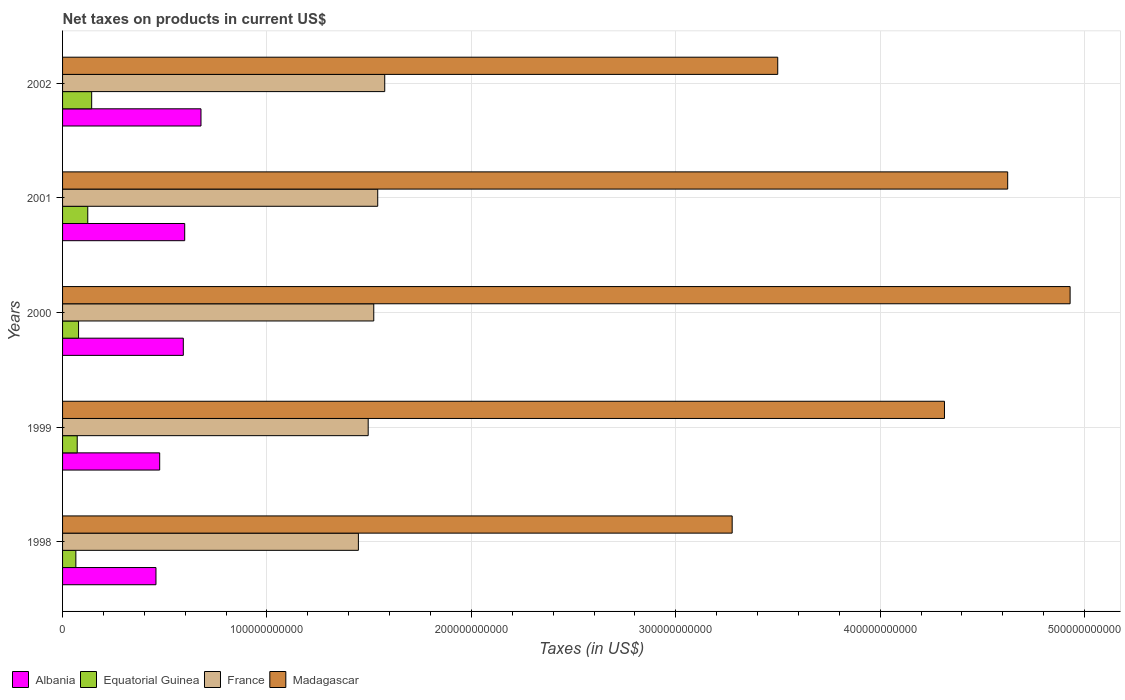How many different coloured bars are there?
Make the answer very short. 4. How many groups of bars are there?
Provide a succinct answer. 5. Are the number of bars per tick equal to the number of legend labels?
Provide a short and direct response. Yes. How many bars are there on the 5th tick from the top?
Your answer should be compact. 4. How many bars are there on the 3rd tick from the bottom?
Make the answer very short. 4. What is the net taxes on products in Madagascar in 2001?
Ensure brevity in your answer.  4.62e+11. Across all years, what is the maximum net taxes on products in Madagascar?
Offer a terse response. 4.93e+11. Across all years, what is the minimum net taxes on products in Equatorial Guinea?
Your response must be concise. 6.50e+09. In which year was the net taxes on products in Equatorial Guinea maximum?
Give a very brief answer. 2002. What is the total net taxes on products in Albania in the graph?
Offer a very short reply. 2.80e+11. What is the difference between the net taxes on products in Equatorial Guinea in 2000 and that in 2002?
Provide a succinct answer. -6.41e+09. What is the difference between the net taxes on products in Albania in 2001 and the net taxes on products in Madagascar in 2002?
Offer a very short reply. -2.90e+11. What is the average net taxes on products in France per year?
Keep it short and to the point. 1.52e+11. In the year 2002, what is the difference between the net taxes on products in France and net taxes on products in Albania?
Offer a very short reply. 8.99e+1. In how many years, is the net taxes on products in Albania greater than 80000000000 US$?
Give a very brief answer. 0. What is the ratio of the net taxes on products in Madagascar in 1998 to that in 2000?
Offer a terse response. 0.66. Is the net taxes on products in Equatorial Guinea in 1998 less than that in 2001?
Provide a succinct answer. Yes. What is the difference between the highest and the second highest net taxes on products in France?
Your response must be concise. 3.43e+09. What is the difference between the highest and the lowest net taxes on products in Equatorial Guinea?
Your answer should be compact. 7.74e+09. What does the 1st bar from the top in 2001 represents?
Your response must be concise. Madagascar. What does the 2nd bar from the bottom in 2002 represents?
Your response must be concise. Equatorial Guinea. How many bars are there?
Ensure brevity in your answer.  20. Are all the bars in the graph horizontal?
Ensure brevity in your answer.  Yes. How many years are there in the graph?
Provide a succinct answer. 5. What is the difference between two consecutive major ticks on the X-axis?
Offer a very short reply. 1.00e+11. Are the values on the major ticks of X-axis written in scientific E-notation?
Ensure brevity in your answer.  No. Where does the legend appear in the graph?
Make the answer very short. Bottom left. How are the legend labels stacked?
Your response must be concise. Horizontal. What is the title of the graph?
Offer a terse response. Net taxes on products in current US$. What is the label or title of the X-axis?
Make the answer very short. Taxes (in US$). What is the Taxes (in US$) in Albania in 1998?
Keep it short and to the point. 4.57e+1. What is the Taxes (in US$) of Equatorial Guinea in 1998?
Your answer should be compact. 6.50e+09. What is the Taxes (in US$) of France in 1998?
Keep it short and to the point. 1.45e+11. What is the Taxes (in US$) of Madagascar in 1998?
Your response must be concise. 3.28e+11. What is the Taxes (in US$) in Albania in 1999?
Keep it short and to the point. 4.75e+1. What is the Taxes (in US$) in Equatorial Guinea in 1999?
Ensure brevity in your answer.  7.16e+09. What is the Taxes (in US$) in France in 1999?
Give a very brief answer. 1.50e+11. What is the Taxes (in US$) of Madagascar in 1999?
Offer a terse response. 4.31e+11. What is the Taxes (in US$) in Albania in 2000?
Your answer should be very brief. 5.91e+1. What is the Taxes (in US$) of Equatorial Guinea in 2000?
Keep it short and to the point. 7.82e+09. What is the Taxes (in US$) of France in 2000?
Keep it short and to the point. 1.52e+11. What is the Taxes (in US$) of Madagascar in 2000?
Provide a short and direct response. 4.93e+11. What is the Taxes (in US$) of Albania in 2001?
Offer a terse response. 5.98e+1. What is the Taxes (in US$) of Equatorial Guinea in 2001?
Provide a short and direct response. 1.23e+1. What is the Taxes (in US$) in France in 2001?
Offer a terse response. 1.54e+11. What is the Taxes (in US$) of Madagascar in 2001?
Offer a terse response. 4.62e+11. What is the Taxes (in US$) in Albania in 2002?
Keep it short and to the point. 6.77e+1. What is the Taxes (in US$) in Equatorial Guinea in 2002?
Your answer should be very brief. 1.42e+1. What is the Taxes (in US$) in France in 2002?
Ensure brevity in your answer.  1.58e+11. What is the Taxes (in US$) of Madagascar in 2002?
Offer a very short reply. 3.50e+11. Across all years, what is the maximum Taxes (in US$) in Albania?
Offer a very short reply. 6.77e+1. Across all years, what is the maximum Taxes (in US$) of Equatorial Guinea?
Give a very brief answer. 1.42e+1. Across all years, what is the maximum Taxes (in US$) in France?
Give a very brief answer. 1.58e+11. Across all years, what is the maximum Taxes (in US$) in Madagascar?
Your response must be concise. 4.93e+11. Across all years, what is the minimum Taxes (in US$) of Albania?
Your answer should be very brief. 4.57e+1. Across all years, what is the minimum Taxes (in US$) of Equatorial Guinea?
Give a very brief answer. 6.50e+09. Across all years, what is the minimum Taxes (in US$) in France?
Ensure brevity in your answer.  1.45e+11. Across all years, what is the minimum Taxes (in US$) in Madagascar?
Offer a very short reply. 3.28e+11. What is the total Taxes (in US$) in Albania in the graph?
Make the answer very short. 2.80e+11. What is the total Taxes (in US$) in Equatorial Guinea in the graph?
Your answer should be compact. 4.81e+1. What is the total Taxes (in US$) in France in the graph?
Provide a succinct answer. 7.58e+11. What is the total Taxes (in US$) of Madagascar in the graph?
Ensure brevity in your answer.  2.06e+12. What is the difference between the Taxes (in US$) of Albania in 1998 and that in 1999?
Offer a terse response. -1.82e+09. What is the difference between the Taxes (in US$) of Equatorial Guinea in 1998 and that in 1999?
Offer a very short reply. -6.64e+08. What is the difference between the Taxes (in US$) in France in 1998 and that in 1999?
Make the answer very short. -4.79e+09. What is the difference between the Taxes (in US$) in Madagascar in 1998 and that in 1999?
Offer a very short reply. -1.04e+11. What is the difference between the Taxes (in US$) in Albania in 1998 and that in 2000?
Provide a short and direct response. -1.34e+1. What is the difference between the Taxes (in US$) in Equatorial Guinea in 1998 and that in 2000?
Give a very brief answer. -1.32e+09. What is the difference between the Taxes (in US$) of France in 1998 and that in 2000?
Keep it short and to the point. -7.52e+09. What is the difference between the Taxes (in US$) of Madagascar in 1998 and that in 2000?
Your answer should be compact. -1.65e+11. What is the difference between the Taxes (in US$) in Albania in 1998 and that in 2001?
Your response must be concise. -1.41e+1. What is the difference between the Taxes (in US$) in Equatorial Guinea in 1998 and that in 2001?
Ensure brevity in your answer.  -5.83e+09. What is the difference between the Taxes (in US$) in France in 1998 and that in 2001?
Keep it short and to the point. -9.46e+09. What is the difference between the Taxes (in US$) in Madagascar in 1998 and that in 2001?
Give a very brief answer. -1.35e+11. What is the difference between the Taxes (in US$) of Albania in 1998 and that in 2002?
Ensure brevity in your answer.  -2.20e+1. What is the difference between the Taxes (in US$) in Equatorial Guinea in 1998 and that in 2002?
Ensure brevity in your answer.  -7.74e+09. What is the difference between the Taxes (in US$) in France in 1998 and that in 2002?
Provide a short and direct response. -1.29e+1. What is the difference between the Taxes (in US$) in Madagascar in 1998 and that in 2002?
Your response must be concise. -2.23e+1. What is the difference between the Taxes (in US$) of Albania in 1999 and that in 2000?
Offer a terse response. -1.16e+1. What is the difference between the Taxes (in US$) of Equatorial Guinea in 1999 and that in 2000?
Keep it short and to the point. -6.58e+08. What is the difference between the Taxes (in US$) in France in 1999 and that in 2000?
Keep it short and to the point. -2.72e+09. What is the difference between the Taxes (in US$) in Madagascar in 1999 and that in 2000?
Provide a short and direct response. -6.15e+1. What is the difference between the Taxes (in US$) in Albania in 1999 and that in 2001?
Your answer should be very brief. -1.22e+1. What is the difference between the Taxes (in US$) in Equatorial Guinea in 1999 and that in 2001?
Give a very brief answer. -5.17e+09. What is the difference between the Taxes (in US$) of France in 1999 and that in 2001?
Provide a succinct answer. -4.66e+09. What is the difference between the Taxes (in US$) in Madagascar in 1999 and that in 2001?
Provide a succinct answer. -3.09e+1. What is the difference between the Taxes (in US$) of Albania in 1999 and that in 2002?
Your answer should be compact. -2.02e+1. What is the difference between the Taxes (in US$) of Equatorial Guinea in 1999 and that in 2002?
Offer a very short reply. -7.07e+09. What is the difference between the Taxes (in US$) of France in 1999 and that in 2002?
Your response must be concise. -8.09e+09. What is the difference between the Taxes (in US$) of Madagascar in 1999 and that in 2002?
Your answer should be very brief. 8.16e+1. What is the difference between the Taxes (in US$) of Albania in 2000 and that in 2001?
Your answer should be compact. -6.84e+08. What is the difference between the Taxes (in US$) in Equatorial Guinea in 2000 and that in 2001?
Your response must be concise. -4.51e+09. What is the difference between the Taxes (in US$) of France in 2000 and that in 2001?
Keep it short and to the point. -1.94e+09. What is the difference between the Taxes (in US$) of Madagascar in 2000 and that in 2001?
Offer a terse response. 3.05e+1. What is the difference between the Taxes (in US$) of Albania in 2000 and that in 2002?
Your answer should be very brief. -8.64e+09. What is the difference between the Taxes (in US$) in Equatorial Guinea in 2000 and that in 2002?
Your response must be concise. -6.41e+09. What is the difference between the Taxes (in US$) in France in 2000 and that in 2002?
Your answer should be very brief. -5.37e+09. What is the difference between the Taxes (in US$) of Madagascar in 2000 and that in 2002?
Make the answer very short. 1.43e+11. What is the difference between the Taxes (in US$) in Albania in 2001 and that in 2002?
Offer a terse response. -7.96e+09. What is the difference between the Taxes (in US$) of Equatorial Guinea in 2001 and that in 2002?
Make the answer very short. -1.91e+09. What is the difference between the Taxes (in US$) in France in 2001 and that in 2002?
Ensure brevity in your answer.  -3.43e+09. What is the difference between the Taxes (in US$) in Madagascar in 2001 and that in 2002?
Your answer should be compact. 1.12e+11. What is the difference between the Taxes (in US$) of Albania in 1998 and the Taxes (in US$) of Equatorial Guinea in 1999?
Provide a short and direct response. 3.85e+1. What is the difference between the Taxes (in US$) in Albania in 1998 and the Taxes (in US$) in France in 1999?
Make the answer very short. -1.04e+11. What is the difference between the Taxes (in US$) of Albania in 1998 and the Taxes (in US$) of Madagascar in 1999?
Your answer should be compact. -3.86e+11. What is the difference between the Taxes (in US$) of Equatorial Guinea in 1998 and the Taxes (in US$) of France in 1999?
Keep it short and to the point. -1.43e+11. What is the difference between the Taxes (in US$) in Equatorial Guinea in 1998 and the Taxes (in US$) in Madagascar in 1999?
Ensure brevity in your answer.  -4.25e+11. What is the difference between the Taxes (in US$) in France in 1998 and the Taxes (in US$) in Madagascar in 1999?
Provide a succinct answer. -2.87e+11. What is the difference between the Taxes (in US$) in Albania in 1998 and the Taxes (in US$) in Equatorial Guinea in 2000?
Keep it short and to the point. 3.79e+1. What is the difference between the Taxes (in US$) of Albania in 1998 and the Taxes (in US$) of France in 2000?
Your answer should be compact. -1.07e+11. What is the difference between the Taxes (in US$) in Albania in 1998 and the Taxes (in US$) in Madagascar in 2000?
Your answer should be very brief. -4.47e+11. What is the difference between the Taxes (in US$) of Equatorial Guinea in 1998 and the Taxes (in US$) of France in 2000?
Keep it short and to the point. -1.46e+11. What is the difference between the Taxes (in US$) of Equatorial Guinea in 1998 and the Taxes (in US$) of Madagascar in 2000?
Give a very brief answer. -4.86e+11. What is the difference between the Taxes (in US$) in France in 1998 and the Taxes (in US$) in Madagascar in 2000?
Keep it short and to the point. -3.48e+11. What is the difference between the Taxes (in US$) in Albania in 1998 and the Taxes (in US$) in Equatorial Guinea in 2001?
Your response must be concise. 3.34e+1. What is the difference between the Taxes (in US$) of Albania in 1998 and the Taxes (in US$) of France in 2001?
Provide a short and direct response. -1.08e+11. What is the difference between the Taxes (in US$) of Albania in 1998 and the Taxes (in US$) of Madagascar in 2001?
Ensure brevity in your answer.  -4.17e+11. What is the difference between the Taxes (in US$) in Equatorial Guinea in 1998 and the Taxes (in US$) in France in 2001?
Your response must be concise. -1.48e+11. What is the difference between the Taxes (in US$) in Equatorial Guinea in 1998 and the Taxes (in US$) in Madagascar in 2001?
Offer a very short reply. -4.56e+11. What is the difference between the Taxes (in US$) in France in 1998 and the Taxes (in US$) in Madagascar in 2001?
Ensure brevity in your answer.  -3.18e+11. What is the difference between the Taxes (in US$) of Albania in 1998 and the Taxes (in US$) of Equatorial Guinea in 2002?
Your response must be concise. 3.15e+1. What is the difference between the Taxes (in US$) in Albania in 1998 and the Taxes (in US$) in France in 2002?
Offer a terse response. -1.12e+11. What is the difference between the Taxes (in US$) in Albania in 1998 and the Taxes (in US$) in Madagascar in 2002?
Your response must be concise. -3.04e+11. What is the difference between the Taxes (in US$) of Equatorial Guinea in 1998 and the Taxes (in US$) of France in 2002?
Keep it short and to the point. -1.51e+11. What is the difference between the Taxes (in US$) of Equatorial Guinea in 1998 and the Taxes (in US$) of Madagascar in 2002?
Provide a succinct answer. -3.43e+11. What is the difference between the Taxes (in US$) of France in 1998 and the Taxes (in US$) of Madagascar in 2002?
Give a very brief answer. -2.05e+11. What is the difference between the Taxes (in US$) of Albania in 1999 and the Taxes (in US$) of Equatorial Guinea in 2000?
Offer a very short reply. 3.97e+1. What is the difference between the Taxes (in US$) in Albania in 1999 and the Taxes (in US$) in France in 2000?
Make the answer very short. -1.05e+11. What is the difference between the Taxes (in US$) of Albania in 1999 and the Taxes (in US$) of Madagascar in 2000?
Your answer should be compact. -4.45e+11. What is the difference between the Taxes (in US$) of Equatorial Guinea in 1999 and the Taxes (in US$) of France in 2000?
Provide a succinct answer. -1.45e+11. What is the difference between the Taxes (in US$) in Equatorial Guinea in 1999 and the Taxes (in US$) in Madagascar in 2000?
Provide a short and direct response. -4.86e+11. What is the difference between the Taxes (in US$) of France in 1999 and the Taxes (in US$) of Madagascar in 2000?
Keep it short and to the point. -3.43e+11. What is the difference between the Taxes (in US$) of Albania in 1999 and the Taxes (in US$) of Equatorial Guinea in 2001?
Ensure brevity in your answer.  3.52e+1. What is the difference between the Taxes (in US$) of Albania in 1999 and the Taxes (in US$) of France in 2001?
Make the answer very short. -1.07e+11. What is the difference between the Taxes (in US$) of Albania in 1999 and the Taxes (in US$) of Madagascar in 2001?
Give a very brief answer. -4.15e+11. What is the difference between the Taxes (in US$) of Equatorial Guinea in 1999 and the Taxes (in US$) of France in 2001?
Provide a short and direct response. -1.47e+11. What is the difference between the Taxes (in US$) of Equatorial Guinea in 1999 and the Taxes (in US$) of Madagascar in 2001?
Provide a succinct answer. -4.55e+11. What is the difference between the Taxes (in US$) in France in 1999 and the Taxes (in US$) in Madagascar in 2001?
Offer a terse response. -3.13e+11. What is the difference between the Taxes (in US$) in Albania in 1999 and the Taxes (in US$) in Equatorial Guinea in 2002?
Give a very brief answer. 3.33e+1. What is the difference between the Taxes (in US$) in Albania in 1999 and the Taxes (in US$) in France in 2002?
Give a very brief answer. -1.10e+11. What is the difference between the Taxes (in US$) of Albania in 1999 and the Taxes (in US$) of Madagascar in 2002?
Ensure brevity in your answer.  -3.02e+11. What is the difference between the Taxes (in US$) in Equatorial Guinea in 1999 and the Taxes (in US$) in France in 2002?
Make the answer very short. -1.50e+11. What is the difference between the Taxes (in US$) in Equatorial Guinea in 1999 and the Taxes (in US$) in Madagascar in 2002?
Make the answer very short. -3.43e+11. What is the difference between the Taxes (in US$) in France in 1999 and the Taxes (in US$) in Madagascar in 2002?
Offer a very short reply. -2.00e+11. What is the difference between the Taxes (in US$) of Albania in 2000 and the Taxes (in US$) of Equatorial Guinea in 2001?
Offer a very short reply. 4.67e+1. What is the difference between the Taxes (in US$) of Albania in 2000 and the Taxes (in US$) of France in 2001?
Make the answer very short. -9.51e+1. What is the difference between the Taxes (in US$) of Albania in 2000 and the Taxes (in US$) of Madagascar in 2001?
Keep it short and to the point. -4.03e+11. What is the difference between the Taxes (in US$) in Equatorial Guinea in 2000 and the Taxes (in US$) in France in 2001?
Offer a terse response. -1.46e+11. What is the difference between the Taxes (in US$) in Equatorial Guinea in 2000 and the Taxes (in US$) in Madagascar in 2001?
Ensure brevity in your answer.  -4.55e+11. What is the difference between the Taxes (in US$) in France in 2000 and the Taxes (in US$) in Madagascar in 2001?
Your response must be concise. -3.10e+11. What is the difference between the Taxes (in US$) of Albania in 2000 and the Taxes (in US$) of Equatorial Guinea in 2002?
Ensure brevity in your answer.  4.48e+1. What is the difference between the Taxes (in US$) in Albania in 2000 and the Taxes (in US$) in France in 2002?
Provide a succinct answer. -9.85e+1. What is the difference between the Taxes (in US$) in Albania in 2000 and the Taxes (in US$) in Madagascar in 2002?
Your response must be concise. -2.91e+11. What is the difference between the Taxes (in US$) in Equatorial Guinea in 2000 and the Taxes (in US$) in France in 2002?
Keep it short and to the point. -1.50e+11. What is the difference between the Taxes (in US$) of Equatorial Guinea in 2000 and the Taxes (in US$) of Madagascar in 2002?
Keep it short and to the point. -3.42e+11. What is the difference between the Taxes (in US$) in France in 2000 and the Taxes (in US$) in Madagascar in 2002?
Keep it short and to the point. -1.98e+11. What is the difference between the Taxes (in US$) in Albania in 2001 and the Taxes (in US$) in Equatorial Guinea in 2002?
Offer a terse response. 4.55e+1. What is the difference between the Taxes (in US$) of Albania in 2001 and the Taxes (in US$) of France in 2002?
Your answer should be compact. -9.79e+1. What is the difference between the Taxes (in US$) of Albania in 2001 and the Taxes (in US$) of Madagascar in 2002?
Give a very brief answer. -2.90e+11. What is the difference between the Taxes (in US$) in Equatorial Guinea in 2001 and the Taxes (in US$) in France in 2002?
Your response must be concise. -1.45e+11. What is the difference between the Taxes (in US$) in Equatorial Guinea in 2001 and the Taxes (in US$) in Madagascar in 2002?
Your answer should be compact. -3.38e+11. What is the difference between the Taxes (in US$) in France in 2001 and the Taxes (in US$) in Madagascar in 2002?
Your response must be concise. -1.96e+11. What is the average Taxes (in US$) in Albania per year?
Provide a short and direct response. 5.60e+1. What is the average Taxes (in US$) of Equatorial Guinea per year?
Offer a very short reply. 9.61e+09. What is the average Taxes (in US$) in France per year?
Offer a terse response. 1.52e+11. What is the average Taxes (in US$) of Madagascar per year?
Your response must be concise. 4.13e+11. In the year 1998, what is the difference between the Taxes (in US$) in Albania and Taxes (in US$) in Equatorial Guinea?
Keep it short and to the point. 3.92e+1. In the year 1998, what is the difference between the Taxes (in US$) in Albania and Taxes (in US$) in France?
Provide a short and direct response. -9.90e+1. In the year 1998, what is the difference between the Taxes (in US$) of Albania and Taxes (in US$) of Madagascar?
Your answer should be very brief. -2.82e+11. In the year 1998, what is the difference between the Taxes (in US$) of Equatorial Guinea and Taxes (in US$) of France?
Provide a succinct answer. -1.38e+11. In the year 1998, what is the difference between the Taxes (in US$) of Equatorial Guinea and Taxes (in US$) of Madagascar?
Provide a short and direct response. -3.21e+11. In the year 1998, what is the difference between the Taxes (in US$) in France and Taxes (in US$) in Madagascar?
Keep it short and to the point. -1.83e+11. In the year 1999, what is the difference between the Taxes (in US$) of Albania and Taxes (in US$) of Equatorial Guinea?
Provide a succinct answer. 4.03e+1. In the year 1999, what is the difference between the Taxes (in US$) of Albania and Taxes (in US$) of France?
Provide a succinct answer. -1.02e+11. In the year 1999, what is the difference between the Taxes (in US$) of Albania and Taxes (in US$) of Madagascar?
Offer a very short reply. -3.84e+11. In the year 1999, what is the difference between the Taxes (in US$) of Equatorial Guinea and Taxes (in US$) of France?
Provide a succinct answer. -1.42e+11. In the year 1999, what is the difference between the Taxes (in US$) of Equatorial Guinea and Taxes (in US$) of Madagascar?
Your answer should be compact. -4.24e+11. In the year 1999, what is the difference between the Taxes (in US$) of France and Taxes (in US$) of Madagascar?
Give a very brief answer. -2.82e+11. In the year 2000, what is the difference between the Taxes (in US$) in Albania and Taxes (in US$) in Equatorial Guinea?
Offer a very short reply. 5.12e+1. In the year 2000, what is the difference between the Taxes (in US$) in Albania and Taxes (in US$) in France?
Give a very brief answer. -9.32e+1. In the year 2000, what is the difference between the Taxes (in US$) of Albania and Taxes (in US$) of Madagascar?
Give a very brief answer. -4.34e+11. In the year 2000, what is the difference between the Taxes (in US$) in Equatorial Guinea and Taxes (in US$) in France?
Keep it short and to the point. -1.44e+11. In the year 2000, what is the difference between the Taxes (in US$) in Equatorial Guinea and Taxes (in US$) in Madagascar?
Offer a very short reply. -4.85e+11. In the year 2000, what is the difference between the Taxes (in US$) of France and Taxes (in US$) of Madagascar?
Ensure brevity in your answer.  -3.41e+11. In the year 2001, what is the difference between the Taxes (in US$) of Albania and Taxes (in US$) of Equatorial Guinea?
Keep it short and to the point. 4.74e+1. In the year 2001, what is the difference between the Taxes (in US$) in Albania and Taxes (in US$) in France?
Provide a short and direct response. -9.44e+1. In the year 2001, what is the difference between the Taxes (in US$) in Albania and Taxes (in US$) in Madagascar?
Offer a terse response. -4.03e+11. In the year 2001, what is the difference between the Taxes (in US$) of Equatorial Guinea and Taxes (in US$) of France?
Provide a short and direct response. -1.42e+11. In the year 2001, what is the difference between the Taxes (in US$) of Equatorial Guinea and Taxes (in US$) of Madagascar?
Make the answer very short. -4.50e+11. In the year 2001, what is the difference between the Taxes (in US$) in France and Taxes (in US$) in Madagascar?
Offer a very short reply. -3.08e+11. In the year 2002, what is the difference between the Taxes (in US$) of Albania and Taxes (in US$) of Equatorial Guinea?
Your answer should be very brief. 5.35e+1. In the year 2002, what is the difference between the Taxes (in US$) in Albania and Taxes (in US$) in France?
Ensure brevity in your answer.  -8.99e+1. In the year 2002, what is the difference between the Taxes (in US$) in Albania and Taxes (in US$) in Madagascar?
Make the answer very short. -2.82e+11. In the year 2002, what is the difference between the Taxes (in US$) of Equatorial Guinea and Taxes (in US$) of France?
Ensure brevity in your answer.  -1.43e+11. In the year 2002, what is the difference between the Taxes (in US$) in Equatorial Guinea and Taxes (in US$) in Madagascar?
Offer a terse response. -3.36e+11. In the year 2002, what is the difference between the Taxes (in US$) in France and Taxes (in US$) in Madagascar?
Your response must be concise. -1.92e+11. What is the ratio of the Taxes (in US$) in Albania in 1998 to that in 1999?
Provide a succinct answer. 0.96. What is the ratio of the Taxes (in US$) in Equatorial Guinea in 1998 to that in 1999?
Your response must be concise. 0.91. What is the ratio of the Taxes (in US$) of France in 1998 to that in 1999?
Your answer should be compact. 0.97. What is the ratio of the Taxes (in US$) of Madagascar in 1998 to that in 1999?
Your response must be concise. 0.76. What is the ratio of the Taxes (in US$) of Albania in 1998 to that in 2000?
Keep it short and to the point. 0.77. What is the ratio of the Taxes (in US$) of Equatorial Guinea in 1998 to that in 2000?
Offer a terse response. 0.83. What is the ratio of the Taxes (in US$) of France in 1998 to that in 2000?
Keep it short and to the point. 0.95. What is the ratio of the Taxes (in US$) of Madagascar in 1998 to that in 2000?
Give a very brief answer. 0.66. What is the ratio of the Taxes (in US$) in Albania in 1998 to that in 2001?
Your answer should be compact. 0.76. What is the ratio of the Taxes (in US$) in Equatorial Guinea in 1998 to that in 2001?
Offer a terse response. 0.53. What is the ratio of the Taxes (in US$) of France in 1998 to that in 2001?
Offer a terse response. 0.94. What is the ratio of the Taxes (in US$) in Madagascar in 1998 to that in 2001?
Ensure brevity in your answer.  0.71. What is the ratio of the Taxes (in US$) in Albania in 1998 to that in 2002?
Your answer should be very brief. 0.67. What is the ratio of the Taxes (in US$) in Equatorial Guinea in 1998 to that in 2002?
Keep it short and to the point. 0.46. What is the ratio of the Taxes (in US$) in France in 1998 to that in 2002?
Your answer should be compact. 0.92. What is the ratio of the Taxes (in US$) in Madagascar in 1998 to that in 2002?
Give a very brief answer. 0.94. What is the ratio of the Taxes (in US$) in Albania in 1999 to that in 2000?
Offer a terse response. 0.8. What is the ratio of the Taxes (in US$) in Equatorial Guinea in 1999 to that in 2000?
Give a very brief answer. 0.92. What is the ratio of the Taxes (in US$) of France in 1999 to that in 2000?
Your answer should be compact. 0.98. What is the ratio of the Taxes (in US$) in Madagascar in 1999 to that in 2000?
Your answer should be compact. 0.88. What is the ratio of the Taxes (in US$) of Albania in 1999 to that in 2001?
Your answer should be compact. 0.8. What is the ratio of the Taxes (in US$) in Equatorial Guinea in 1999 to that in 2001?
Keep it short and to the point. 0.58. What is the ratio of the Taxes (in US$) in France in 1999 to that in 2001?
Provide a short and direct response. 0.97. What is the ratio of the Taxes (in US$) of Madagascar in 1999 to that in 2001?
Ensure brevity in your answer.  0.93. What is the ratio of the Taxes (in US$) of Albania in 1999 to that in 2002?
Make the answer very short. 0.7. What is the ratio of the Taxes (in US$) in Equatorial Guinea in 1999 to that in 2002?
Give a very brief answer. 0.5. What is the ratio of the Taxes (in US$) of France in 1999 to that in 2002?
Your answer should be very brief. 0.95. What is the ratio of the Taxes (in US$) in Madagascar in 1999 to that in 2002?
Your response must be concise. 1.23. What is the ratio of the Taxes (in US$) of Albania in 2000 to that in 2001?
Provide a short and direct response. 0.99. What is the ratio of the Taxes (in US$) of Equatorial Guinea in 2000 to that in 2001?
Make the answer very short. 0.63. What is the ratio of the Taxes (in US$) of France in 2000 to that in 2001?
Your response must be concise. 0.99. What is the ratio of the Taxes (in US$) in Madagascar in 2000 to that in 2001?
Your answer should be compact. 1.07. What is the ratio of the Taxes (in US$) of Albania in 2000 to that in 2002?
Your response must be concise. 0.87. What is the ratio of the Taxes (in US$) in Equatorial Guinea in 2000 to that in 2002?
Make the answer very short. 0.55. What is the ratio of the Taxes (in US$) in France in 2000 to that in 2002?
Your answer should be compact. 0.97. What is the ratio of the Taxes (in US$) in Madagascar in 2000 to that in 2002?
Your answer should be compact. 1.41. What is the ratio of the Taxes (in US$) of Albania in 2001 to that in 2002?
Make the answer very short. 0.88. What is the ratio of the Taxes (in US$) in Equatorial Guinea in 2001 to that in 2002?
Give a very brief answer. 0.87. What is the ratio of the Taxes (in US$) of France in 2001 to that in 2002?
Offer a terse response. 0.98. What is the ratio of the Taxes (in US$) of Madagascar in 2001 to that in 2002?
Offer a terse response. 1.32. What is the difference between the highest and the second highest Taxes (in US$) in Albania?
Ensure brevity in your answer.  7.96e+09. What is the difference between the highest and the second highest Taxes (in US$) in Equatorial Guinea?
Make the answer very short. 1.91e+09. What is the difference between the highest and the second highest Taxes (in US$) of France?
Make the answer very short. 3.43e+09. What is the difference between the highest and the second highest Taxes (in US$) of Madagascar?
Your answer should be very brief. 3.05e+1. What is the difference between the highest and the lowest Taxes (in US$) of Albania?
Your answer should be very brief. 2.20e+1. What is the difference between the highest and the lowest Taxes (in US$) of Equatorial Guinea?
Offer a very short reply. 7.74e+09. What is the difference between the highest and the lowest Taxes (in US$) in France?
Provide a short and direct response. 1.29e+1. What is the difference between the highest and the lowest Taxes (in US$) in Madagascar?
Keep it short and to the point. 1.65e+11. 